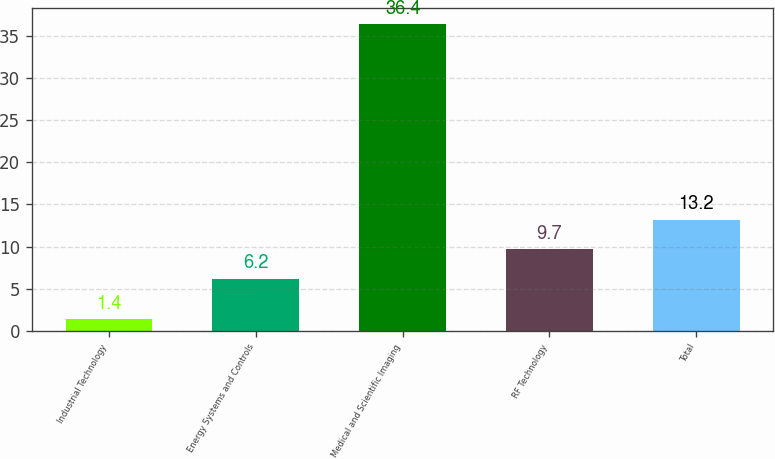Convert chart. <chart><loc_0><loc_0><loc_500><loc_500><bar_chart><fcel>Industrial Technology<fcel>Energy Systems and Controls<fcel>Medical and Scientific Imaging<fcel>RF Technology<fcel>Total<nl><fcel>1.4<fcel>6.2<fcel>36.4<fcel>9.7<fcel>13.2<nl></chart> 